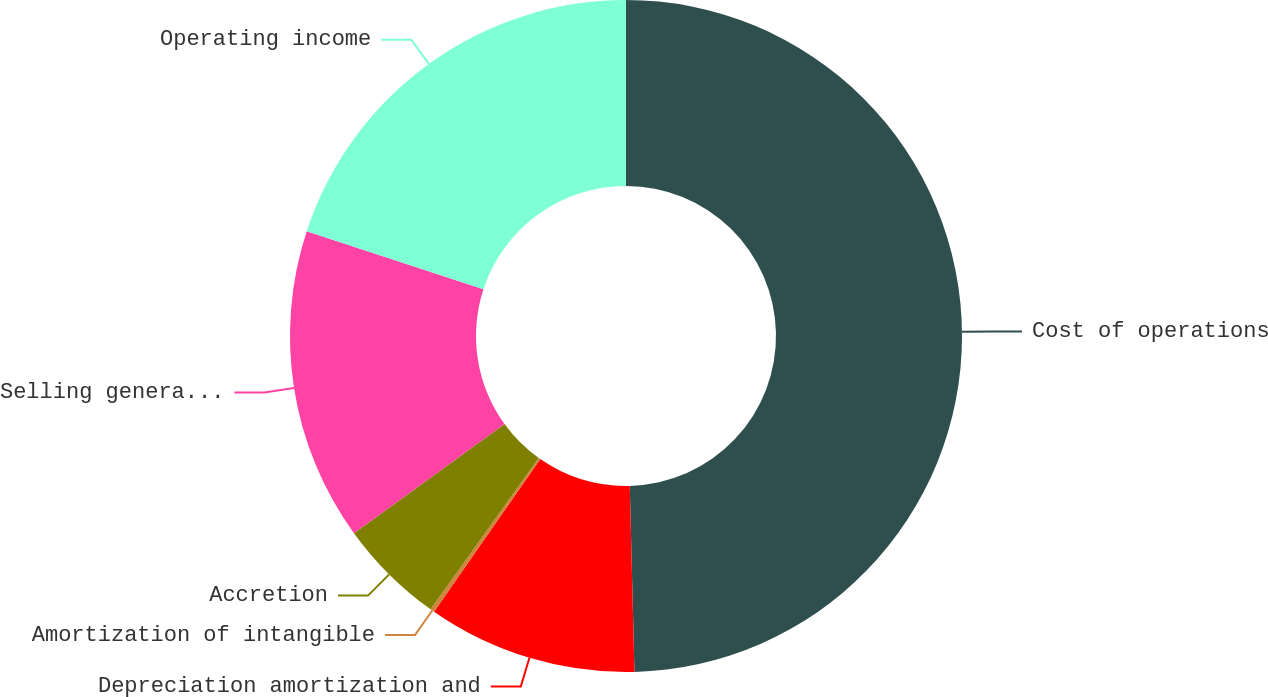Convert chart to OTSL. <chart><loc_0><loc_0><loc_500><loc_500><pie_chart><fcel>Cost of operations<fcel>Depreciation amortization and<fcel>Amortization of intangible<fcel>Accretion<fcel>Selling general and<fcel>Operating income<nl><fcel>49.6%<fcel>10.08%<fcel>0.2%<fcel>5.14%<fcel>15.02%<fcel>19.96%<nl></chart> 